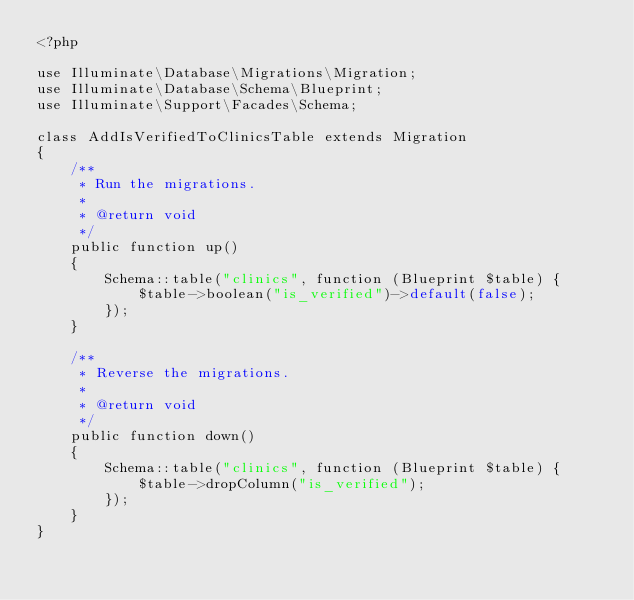<code> <loc_0><loc_0><loc_500><loc_500><_PHP_><?php

use Illuminate\Database\Migrations\Migration;
use Illuminate\Database\Schema\Blueprint;
use Illuminate\Support\Facades\Schema;

class AddIsVerifiedToClinicsTable extends Migration
{
    /**
     * Run the migrations.
     *
     * @return void
     */
    public function up()
    {
        Schema::table("clinics", function (Blueprint $table) {
            $table->boolean("is_verified")->default(false);
        });
    }

    /**
     * Reverse the migrations.
     *
     * @return void
     */
    public function down()
    {
        Schema::table("clinics", function (Blueprint $table) {
            $table->dropColumn("is_verified");
        });
    }
}
</code> 